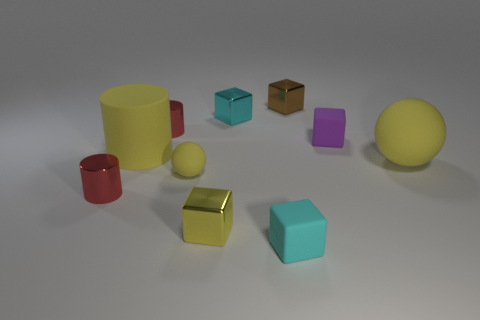Subtract all small cylinders. How many cylinders are left? 1 Subtract all brown blocks. How many blocks are left? 4 Subtract 2 blocks. How many blocks are left? 3 Subtract all green spheres. How many red cylinders are left? 2 Subtract all spheres. How many objects are left? 8 Subtract all brown cylinders. Subtract all red cubes. How many cylinders are left? 3 Subtract all purple rubber objects. Subtract all yellow cubes. How many objects are left? 8 Add 7 cylinders. How many cylinders are left? 10 Add 4 tiny brown objects. How many tiny brown objects exist? 5 Subtract 0 gray cylinders. How many objects are left? 10 